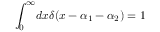<formula> <loc_0><loc_0><loc_500><loc_500>{ \int _ { 0 } ^ { \infty } } d x \delta ( x - \alpha _ { 1 } - \alpha _ { 2 } ) = 1</formula> 